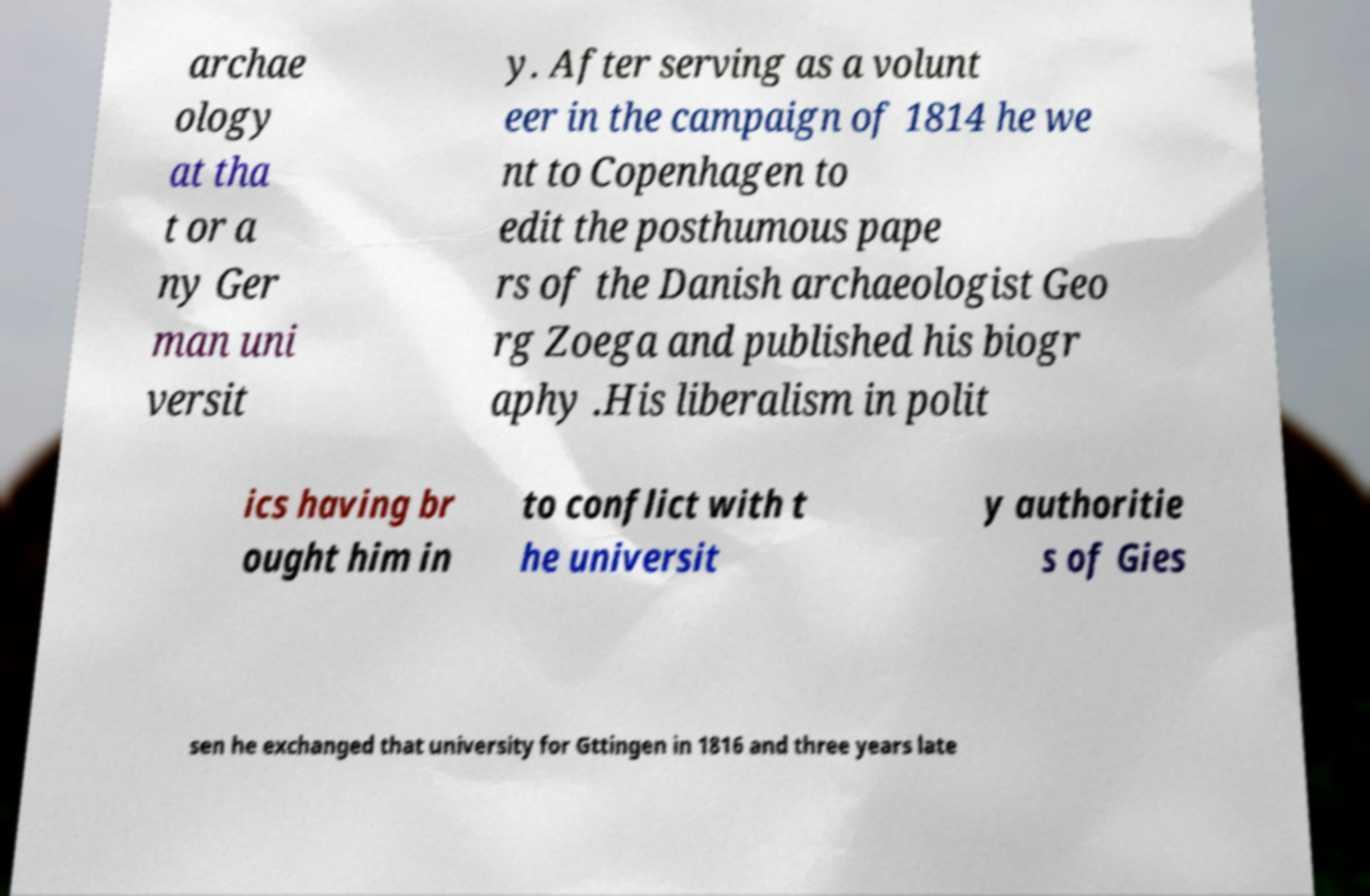For documentation purposes, I need the text within this image transcribed. Could you provide that? archae ology at tha t or a ny Ger man uni versit y. After serving as a volunt eer in the campaign of 1814 he we nt to Copenhagen to edit the posthumous pape rs of the Danish archaeologist Geo rg Zoega and published his biogr aphy .His liberalism in polit ics having br ought him in to conflict with t he universit y authoritie s of Gies sen he exchanged that university for Gttingen in 1816 and three years late 